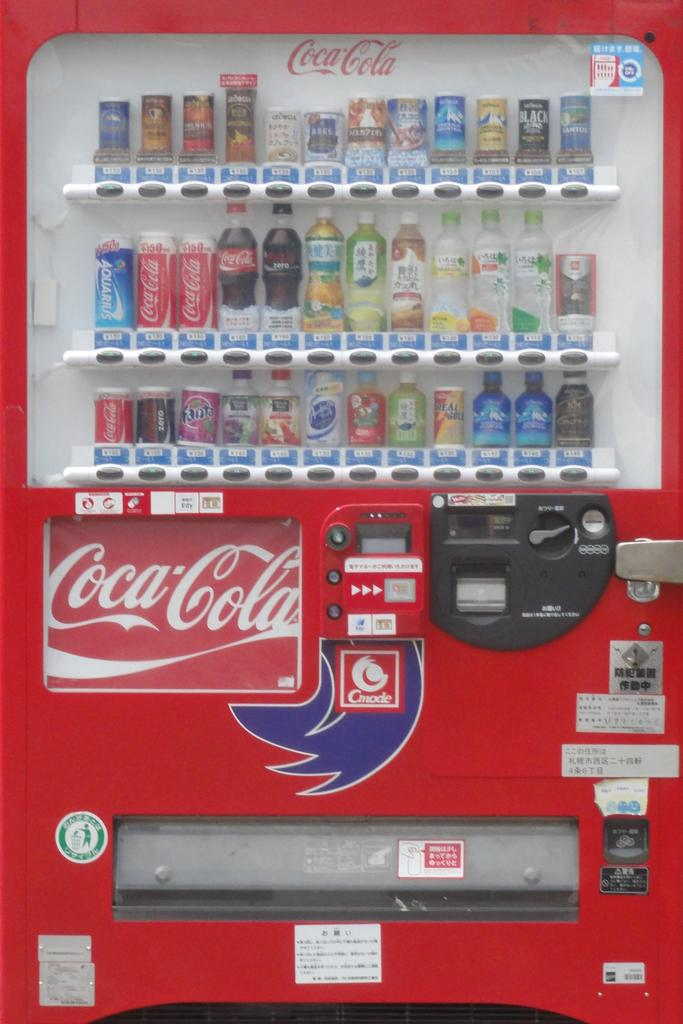<image>
Relay a brief, clear account of the picture shown. A vending machine contains Coke, Coke Zero, Fanta and many other beverages. 